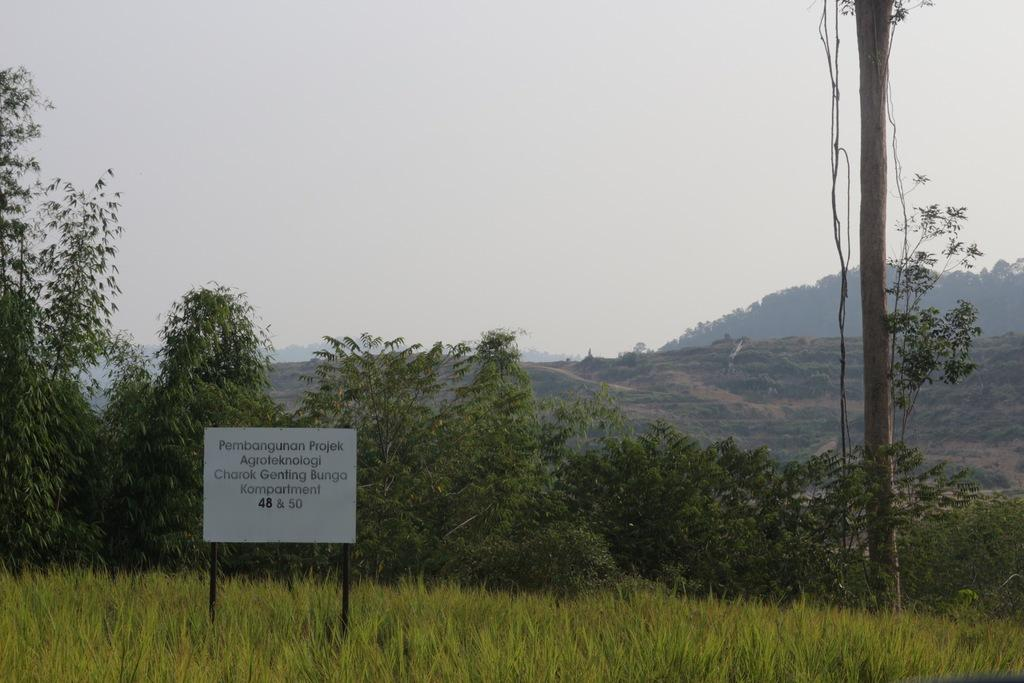What geographical features are located in the center of the image? There are hills and trees in the center of the image. What type of vegetation can be seen at the bottom of the image? There are plants at the bottom of the image. What object is present at the bottom of the image? There is a board at the bottom of the image. What is visible at the top of the image? The sky is visible at the top of the image. Can you tell me how many owls are perched on the trees in the image? There are no owls present in the image; it features hills, trees, plants, a board, and the sky. What type of apparel is being compared in the image? There is no apparel or comparison present in the image. 